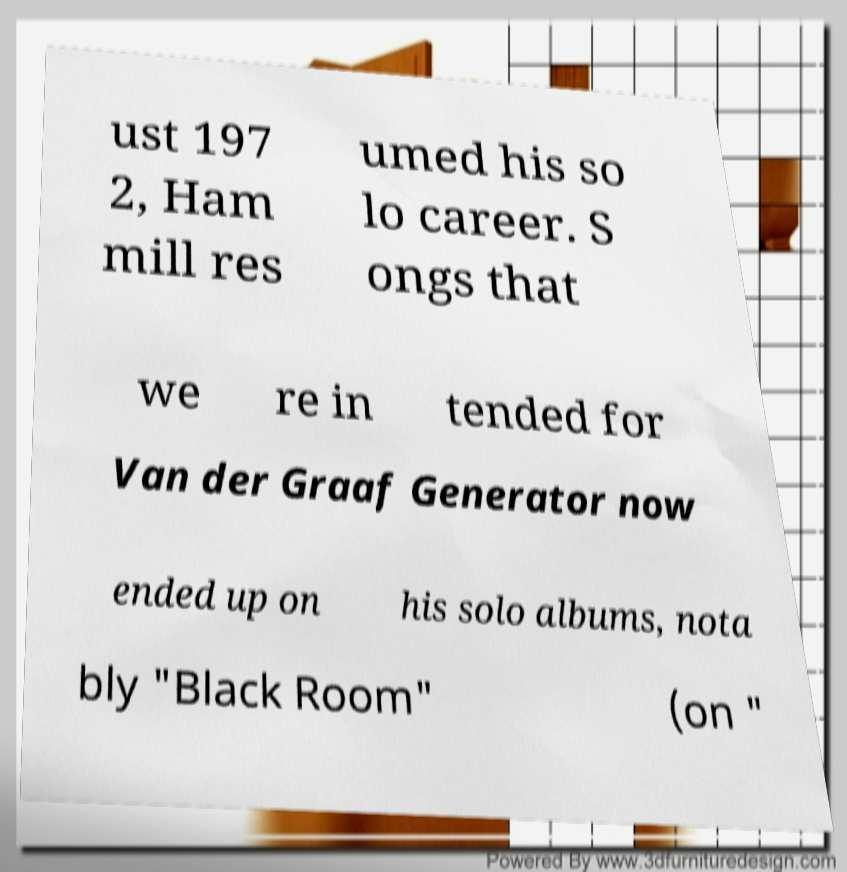What messages or text are displayed in this image? I need them in a readable, typed format. ust 197 2, Ham mill res umed his so lo career. S ongs that we re in tended for Van der Graaf Generator now ended up on his solo albums, nota bly "Black Room" (on " 